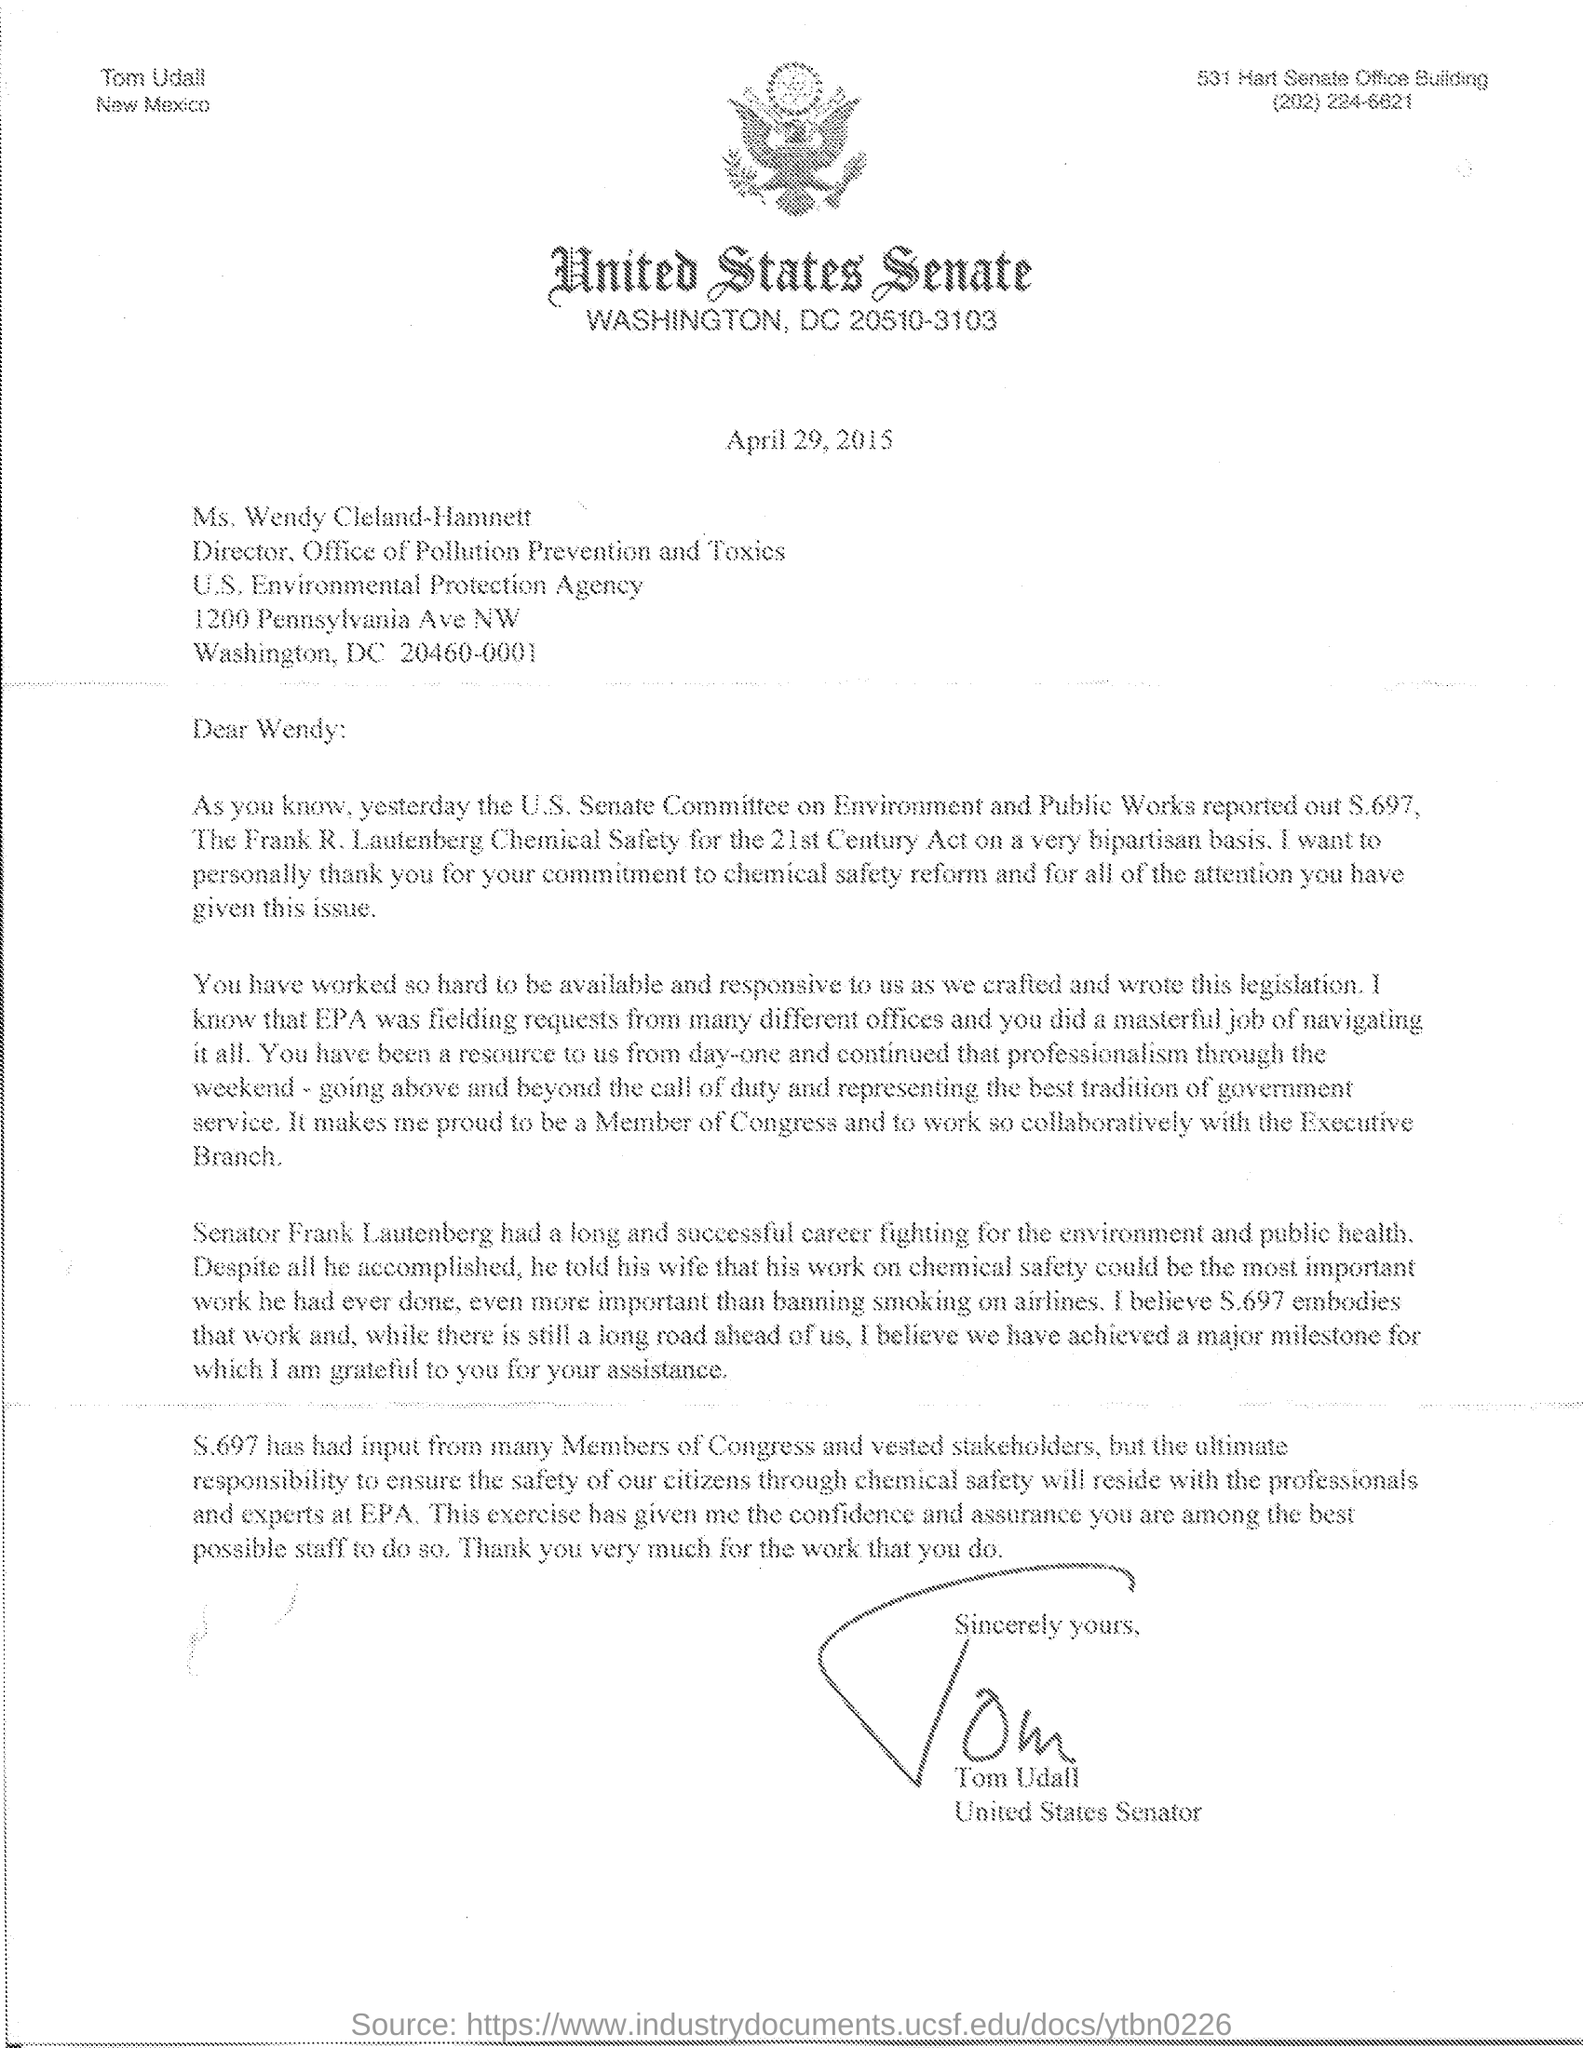Who has signed this letter?
Offer a very short reply. Tom Udall. What is the designation of Tom Udall?
Your answer should be very brief. United States Senator. What is this letter dated?
Provide a short and direct response. April 29, 2015. Who is the addressee of this letter?
Your response must be concise. Wendy. What is the designation of Ms. Wendy Cleland-Hamnett?
Your answer should be compact. Director. Who had a long and successful career fighting for the environment and public health?
Your answer should be very brief. Senator Frank Lautenberg. 